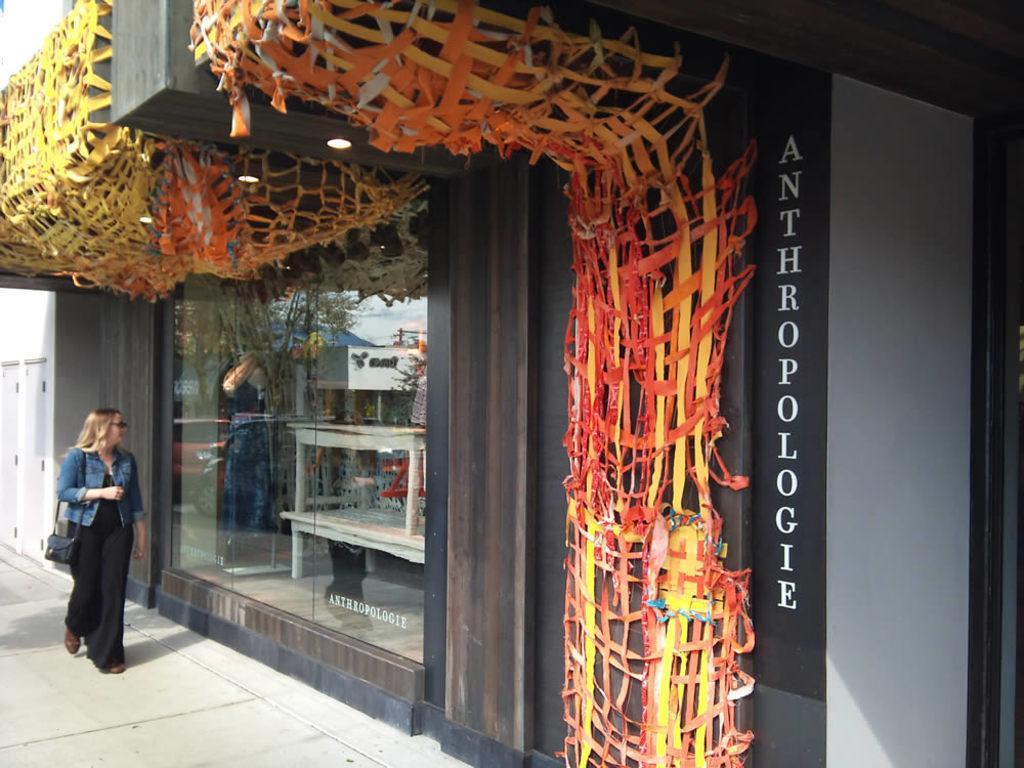Can you describe this image briefly? In this picture we can see a building in the front, there is a woman walking on the left side, we can see lights, ribbons and a glass in the middle, on the right side there is some text. 